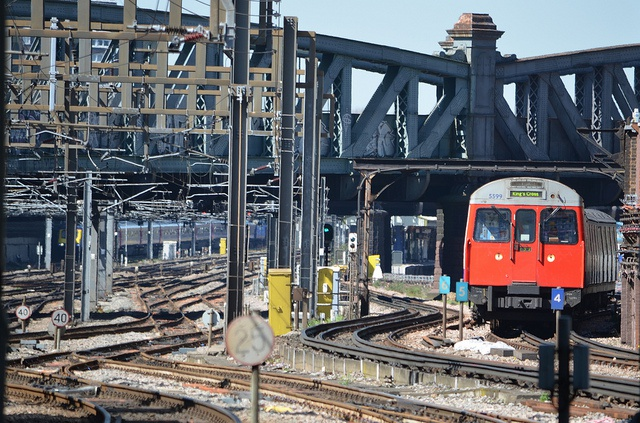Describe the objects in this image and their specific colors. I can see train in black, gray, salmon, and red tones and train in black, gray, navy, and darkblue tones in this image. 